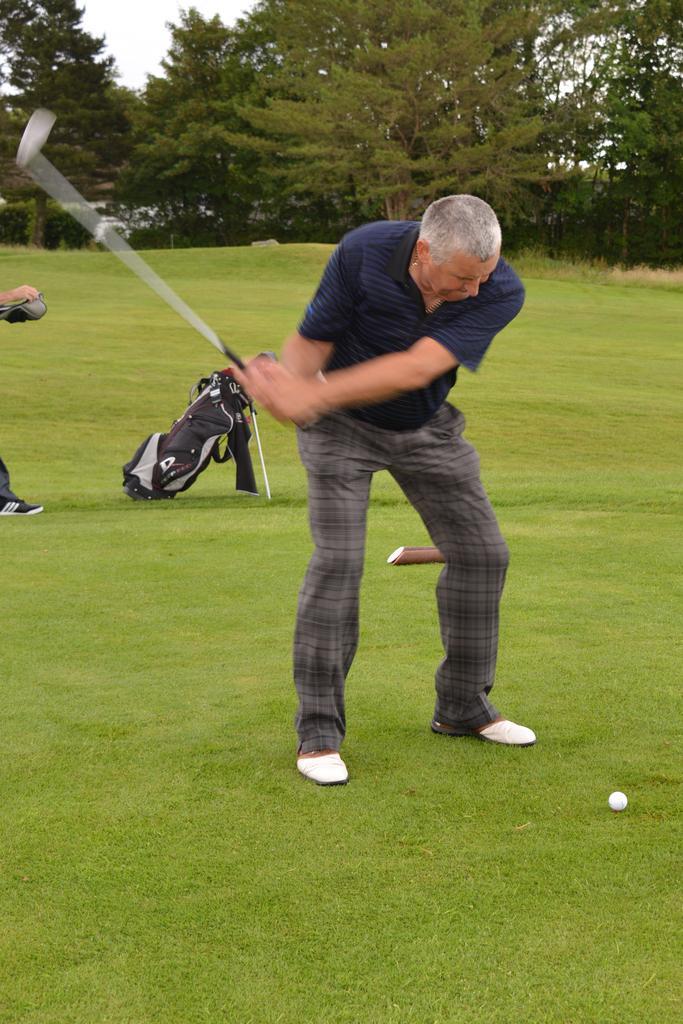Describe this image in one or two sentences. In this image we can see a person wearing blue color T-shirt is holding a golf bat standing on the lawn, here we can see a ball, bag, a person standing here and trees in the background. 